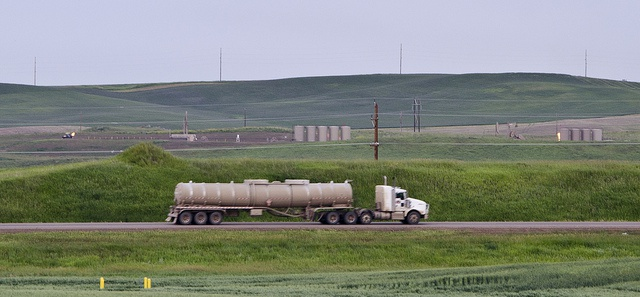Describe the objects in this image and their specific colors. I can see a truck in lavender, darkgray, black, and gray tones in this image. 